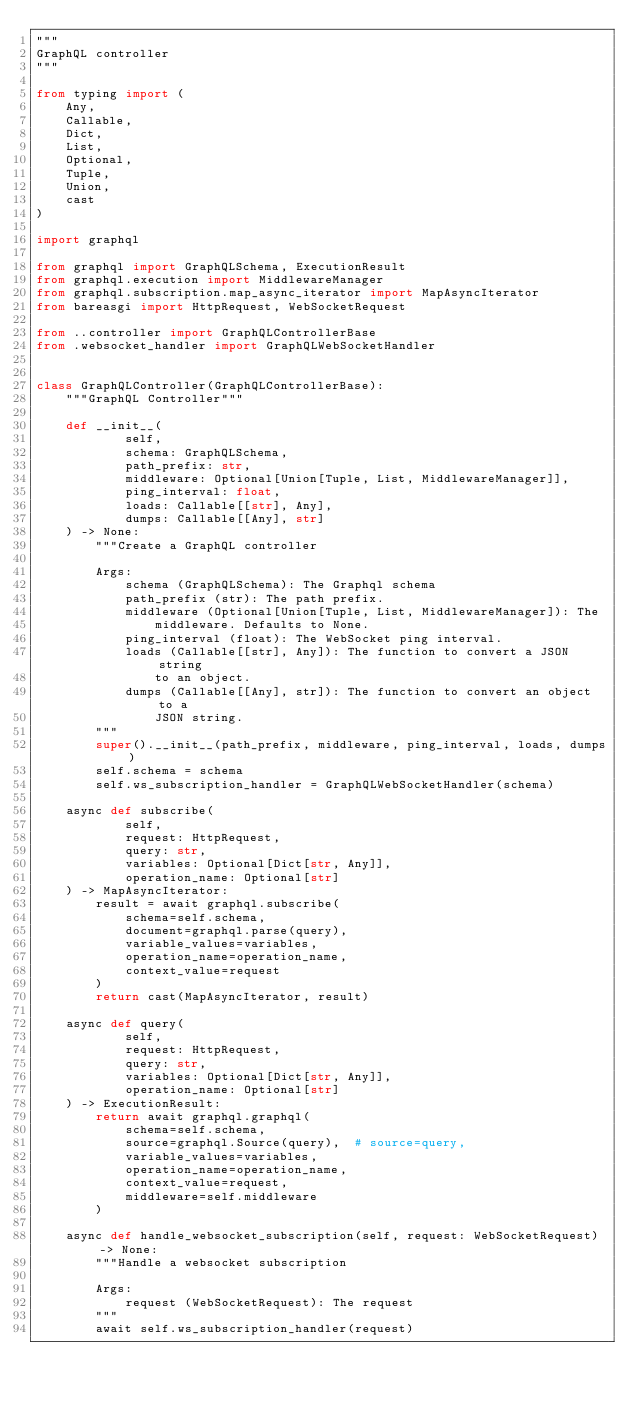Convert code to text. <code><loc_0><loc_0><loc_500><loc_500><_Python_>"""
GraphQL controller
"""

from typing import (
    Any,
    Callable,
    Dict,
    List,
    Optional,
    Tuple,
    Union,
    cast
)

import graphql

from graphql import GraphQLSchema, ExecutionResult
from graphql.execution import MiddlewareManager
from graphql.subscription.map_async_iterator import MapAsyncIterator
from bareasgi import HttpRequest, WebSocketRequest

from ..controller import GraphQLControllerBase
from .websocket_handler import GraphQLWebSocketHandler


class GraphQLController(GraphQLControllerBase):
    """GraphQL Controller"""

    def __init__(
            self,
            schema: GraphQLSchema,
            path_prefix: str,
            middleware: Optional[Union[Tuple, List, MiddlewareManager]],
            ping_interval: float,
            loads: Callable[[str], Any],
            dumps: Callable[[Any], str]
    ) -> None:
        """Create a GraphQL controller

        Args:
            schema (GraphQLSchema): The Graphql schema
            path_prefix (str): The path prefix.
            middleware (Optional[Union[Tuple, List, MiddlewareManager]): The
                middleware. Defaults to None.
            ping_interval (float): The WebSocket ping interval.
            loads (Callable[[str], Any]): The function to convert a JSON string
                to an object.
            dumps (Callable[[Any], str]): The function to convert an object to a
                JSON string.
        """
        super().__init__(path_prefix, middleware, ping_interval, loads, dumps)
        self.schema = schema
        self.ws_subscription_handler = GraphQLWebSocketHandler(schema)

    async def subscribe(
            self,
            request: HttpRequest,
            query: str,
            variables: Optional[Dict[str, Any]],
            operation_name: Optional[str]
    ) -> MapAsyncIterator:
        result = await graphql.subscribe(
            schema=self.schema,
            document=graphql.parse(query),
            variable_values=variables,
            operation_name=operation_name,
            context_value=request
        )
        return cast(MapAsyncIterator, result)

    async def query(
            self,
            request: HttpRequest,
            query: str,
            variables: Optional[Dict[str, Any]],
            operation_name: Optional[str]
    ) -> ExecutionResult:
        return await graphql.graphql(
            schema=self.schema,
            source=graphql.Source(query),  # source=query,
            variable_values=variables,
            operation_name=operation_name,
            context_value=request,
            middleware=self.middleware
        )

    async def handle_websocket_subscription(self, request: WebSocketRequest) -> None:
        """Handle a websocket subscription

        Args:
            request (WebSocketRequest): The request
        """
        await self.ws_subscription_handler(request)
</code> 